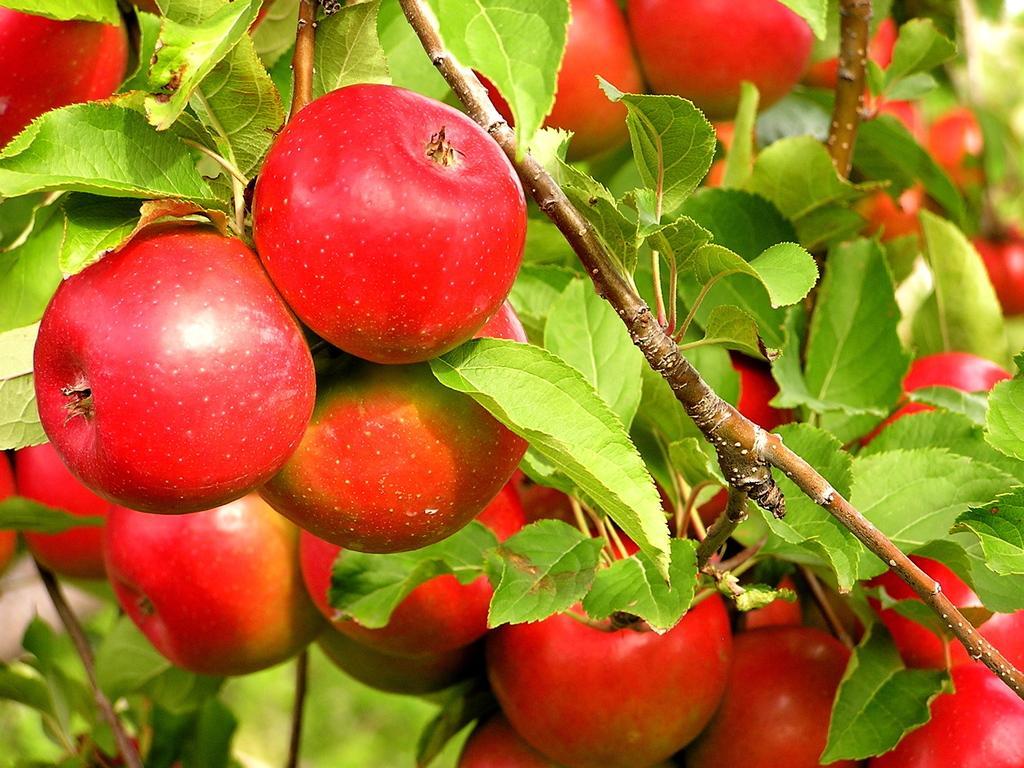Can you describe this image briefly? In this image there is a tree and we can see fruits to it. 